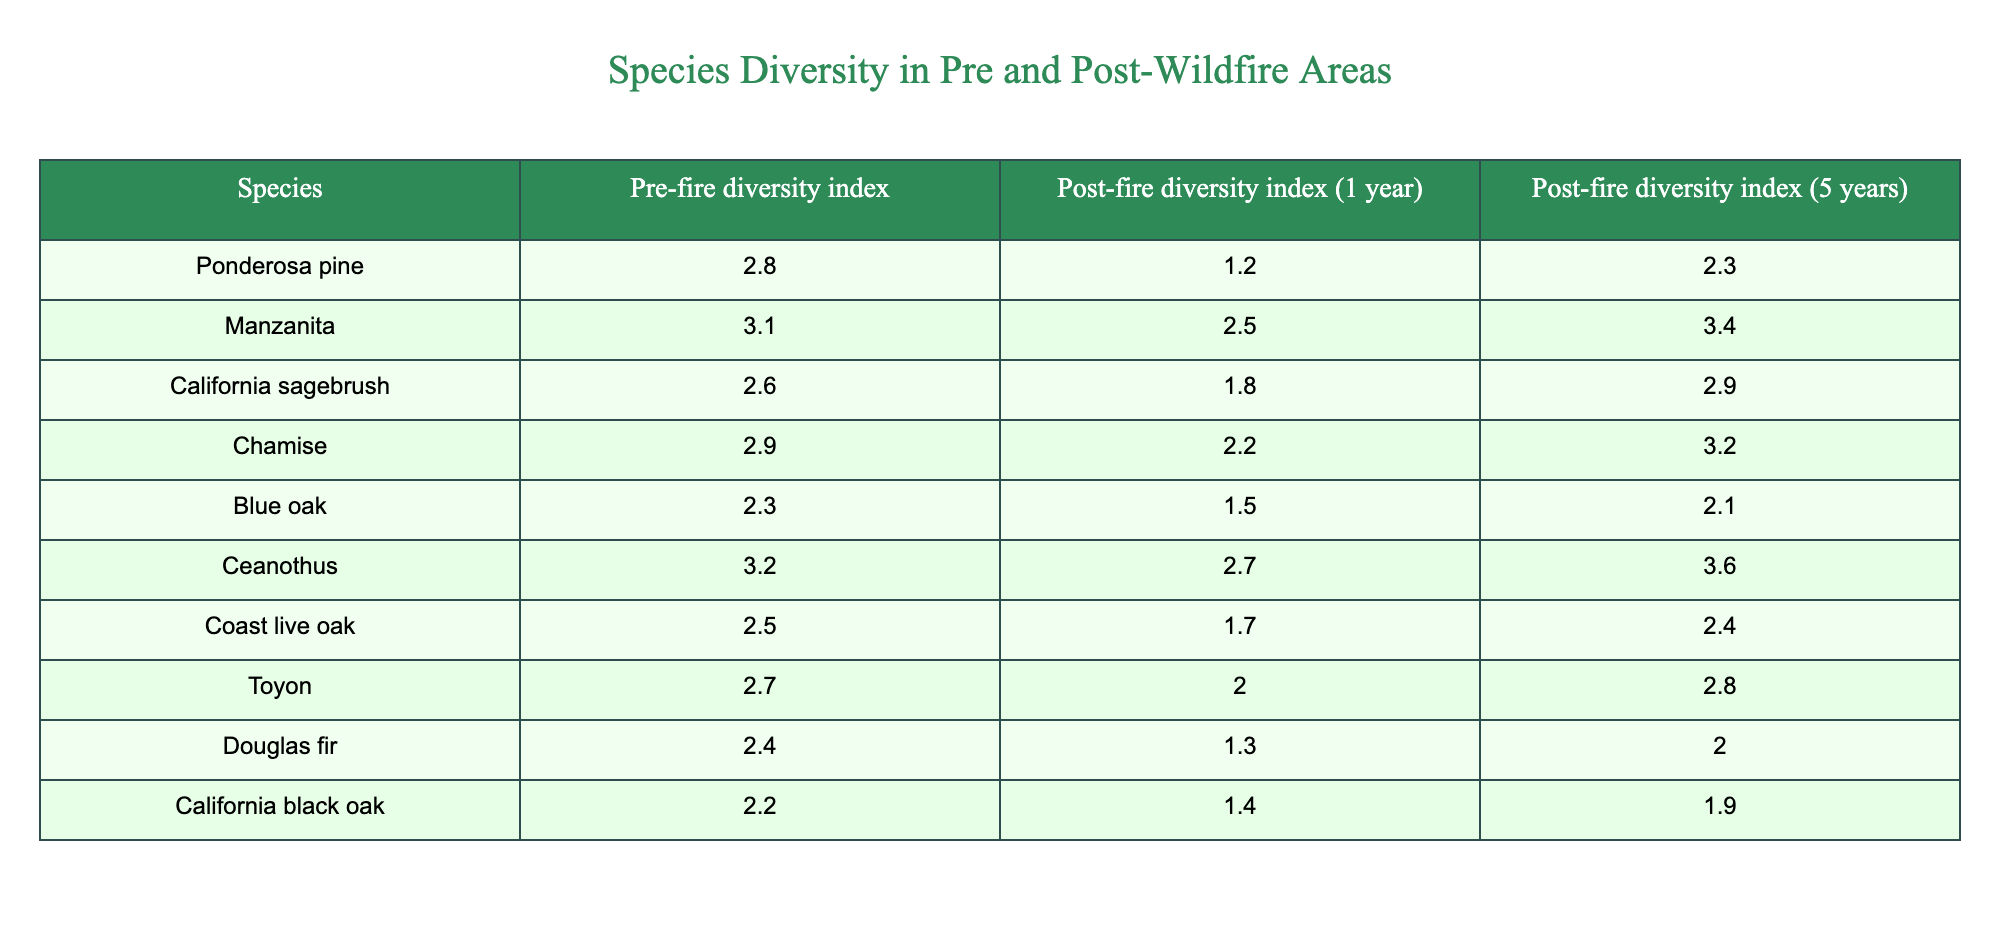What is the pre-fire diversity index of Manzanita? The value is directly provided in the table under the column "Pre-fire diversity index" for the species Manzanita. According to the table, the value is 3.1.
Answer: 3.1 Which species showed the least post-fire diversity index after 1 year? We need to compare the values in the "Post-fire diversity index (1 year)" column. The lowest value among the species is 1.2 for Ponderosa pine.
Answer: Ponderosa pine What is the difference in the post-fire diversity index for California sagebrush between 1 year and 5 years? The post-fire diversity index for California sagebrush at 1 year is 1.8, and at 5 years it is 2.9. The difference can be calculated as 2.9 - 1.8 = 1.1.
Answer: 1.1 Is the post-fire diversity index of Chamise at 5 years higher than its pre-fire diversity index? The pre-fire index for Chamise is 2.9, and the post-fire index at 5 years is 3.2. Since 3.2 is greater than 2.9, the statement is true.
Answer: Yes What is the average pre-fire diversity index of the species listed? To find the average, we sum the pre-fire diversity indices: 2.8 + 3.1 + 2.6 + 2.9 + 2.3 + 3.2 + 2.5 + 2.7 + 2.4 + 2.2 = 28.7. There are 10 species, so the average is 28.7 / 10 = 2.87.
Answer: 2.87 Which species had the highest post-fire diversity index at 5 years? By reviewing the "Post-fire diversity index (5 years)" column, we find that Ceanothus has the highest value of 3.6 among all species at 5 years.
Answer: Ceanothus Is there a species that has a higher diversity index at 5 years post-fire compared to its diversity index one year post-fire? Yes, Manzanita has a post-fire diversity index of 2.5 at 1 year and 3.4 at 5 years, indicating it increased over the years.
Answer: Yes What is the combined post-fire diversity index of Blue oak after 1 and 5 years? The post-fire indices for Blue oak are 1.5 (1 year) and 2.1 (5 years). When we combine these, we add them: 1.5 + 2.1 = 3.6.
Answer: 3.6 